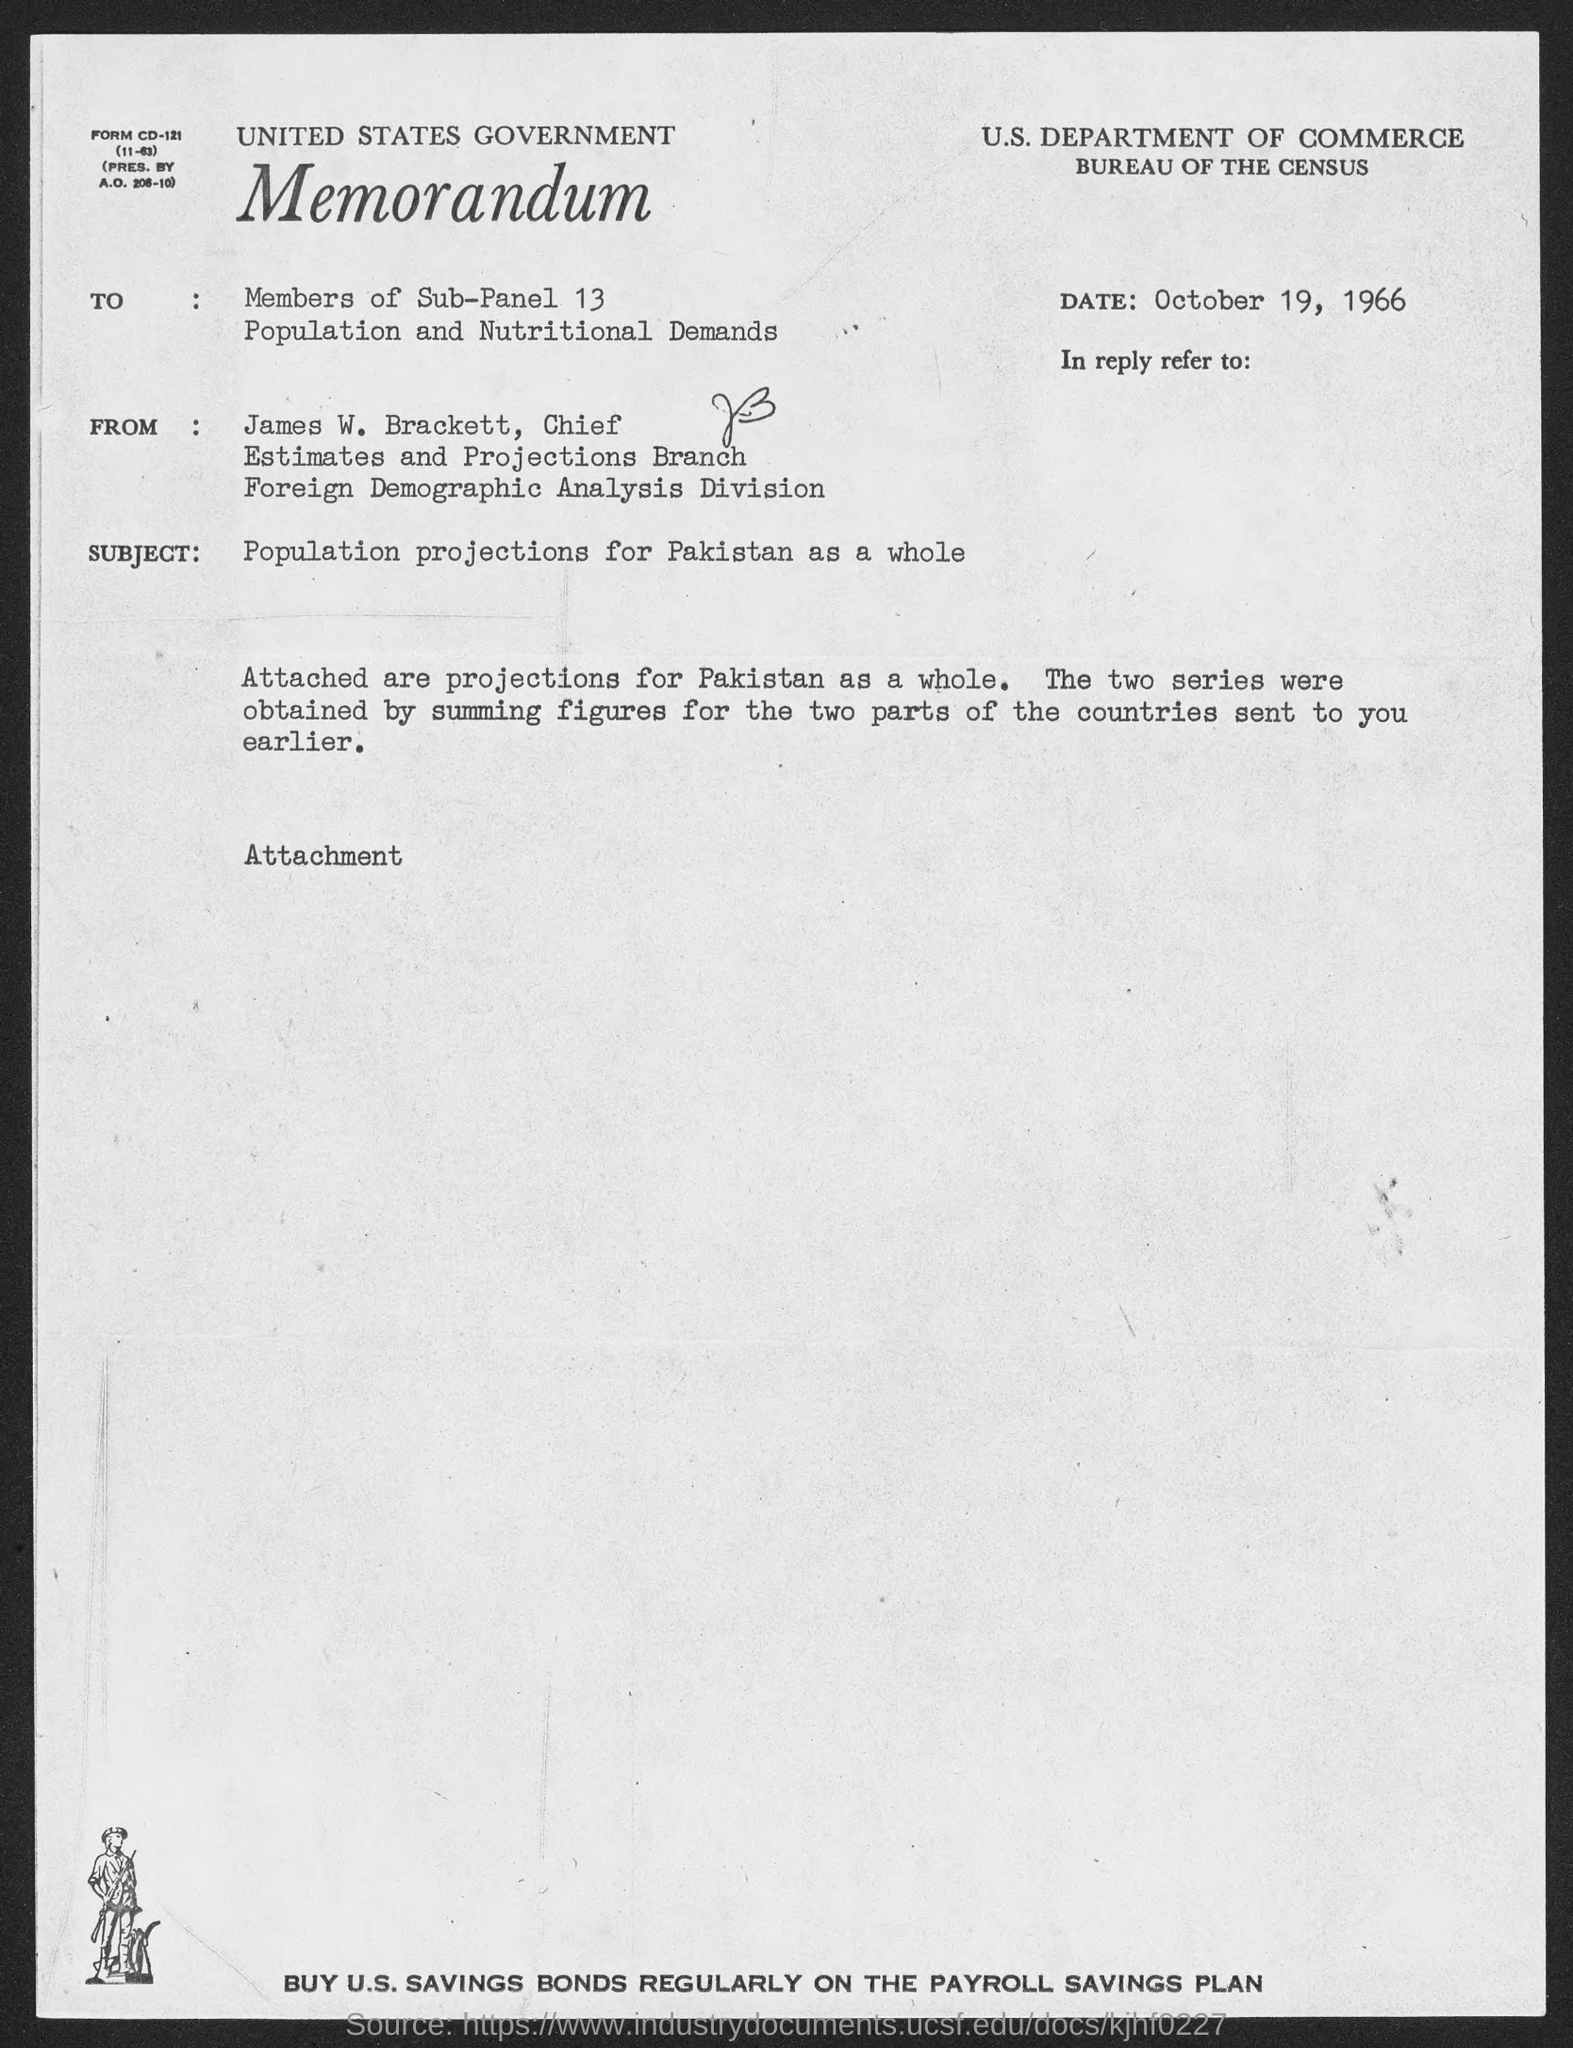Highlight a few significant elements in this photo. The memorandum was dated October 19, 1966. James W. Brackett holds the position of chief. The subject of the memorandum is the population projections for Pakistan as a whole. 